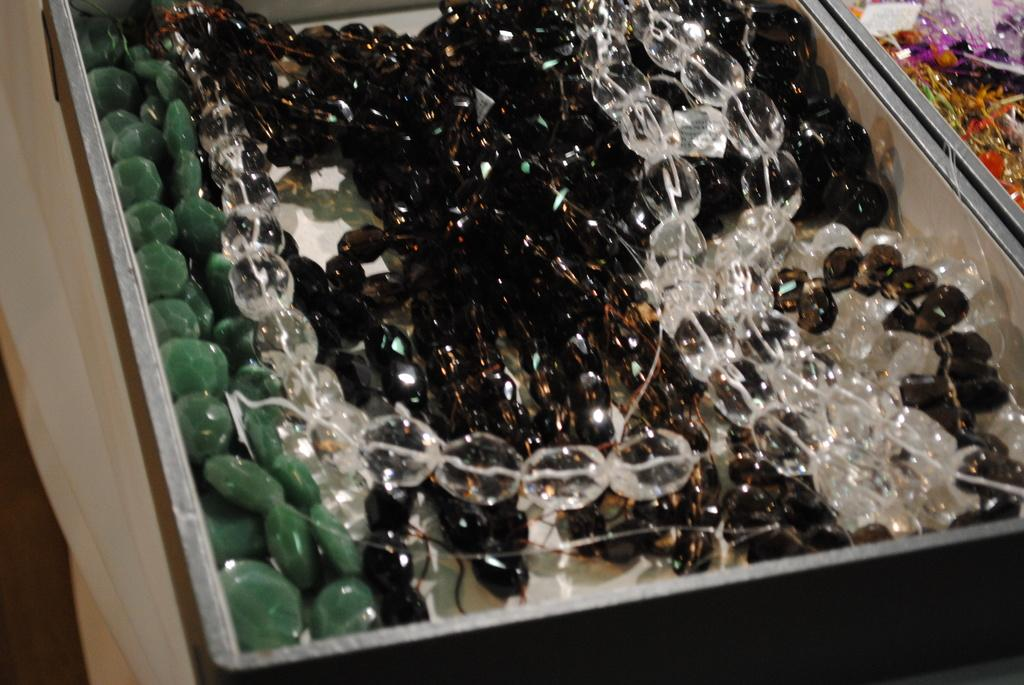What type of objects are in the image? There are marble pearls in the image. What colors are the marble pearls? The marble pearls are in green, white, and black colors. Where are the marble pearls placed? The pearls are placed in a box. What can be seen beside the box in the image? There is a white wall beside the box in the image. How many visitors are present in the image? There are no visitors present in the image; it only features marble pearls in a box and a white wall. What type of airplane is flying in the image? There is no airplane present in the image. 